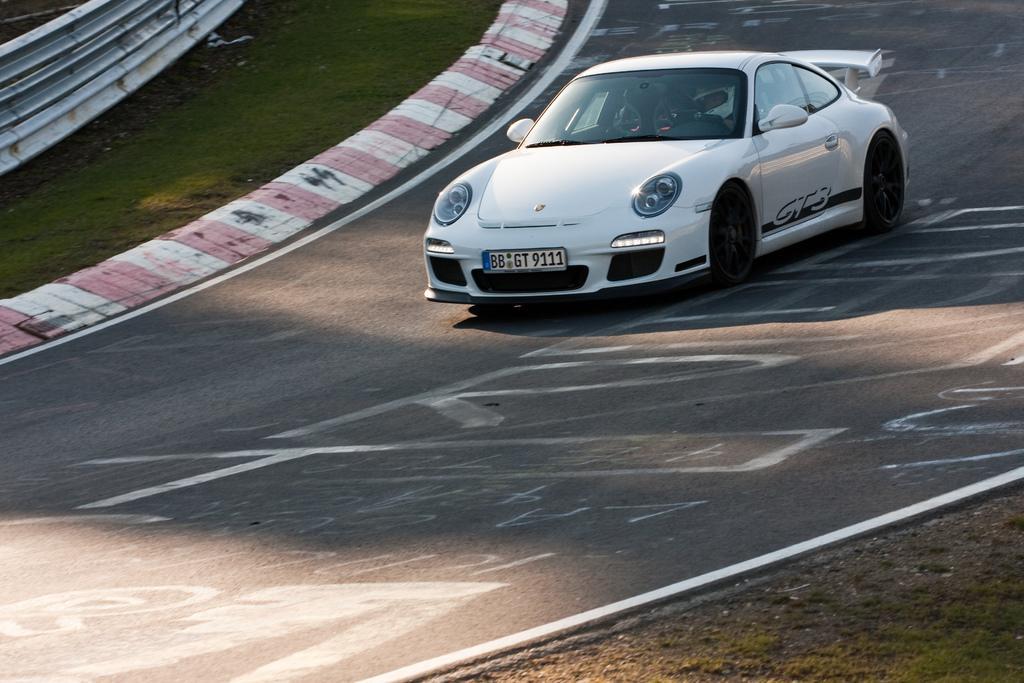Describe this image in one or two sentences. In this image there is a white color race car on the path, and at the background there is iron sheet, grass. 